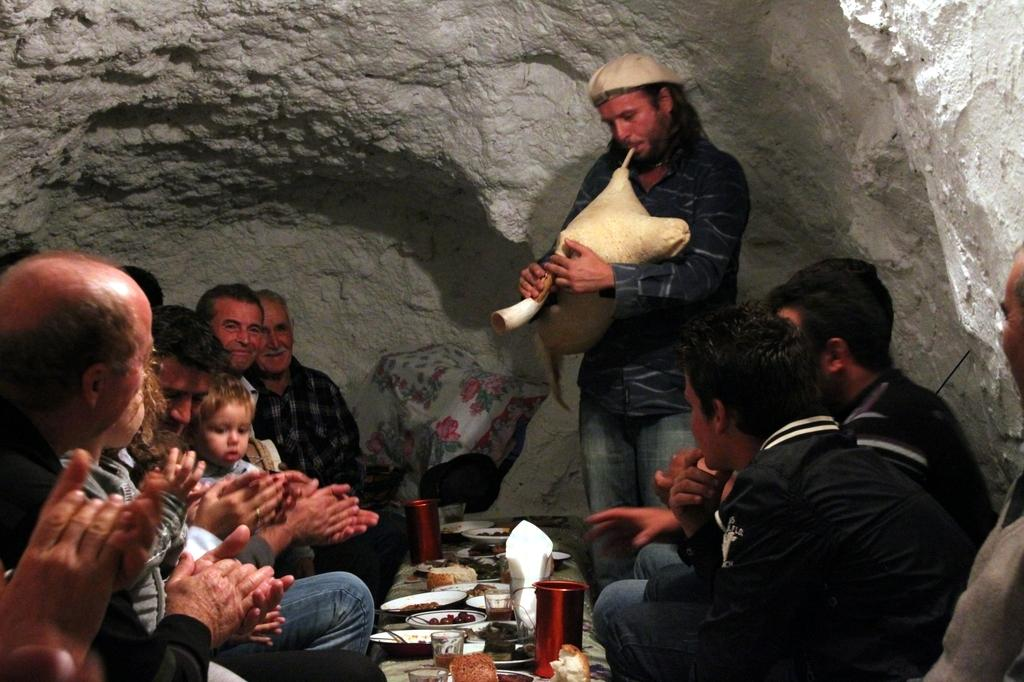How many people are in the image? There are people in the image, but the exact number is not specified. What objects are present in the image that are typically used for eating or drinking? There are plates and glasses in the image. What type of food can be seen in the image? There is food in the image. What else is present in the image besides the people, plates, glasses, and food? There are other objects in the image. What is a person doing with an object in the image? A person is holding an object in the image. What can be seen in the background of the image? There is a rock in the background of the image. What type of picture is the person holding in the image? There is no mention of a picture in the image, so it cannot be determined what type of picture the person might be holding. 